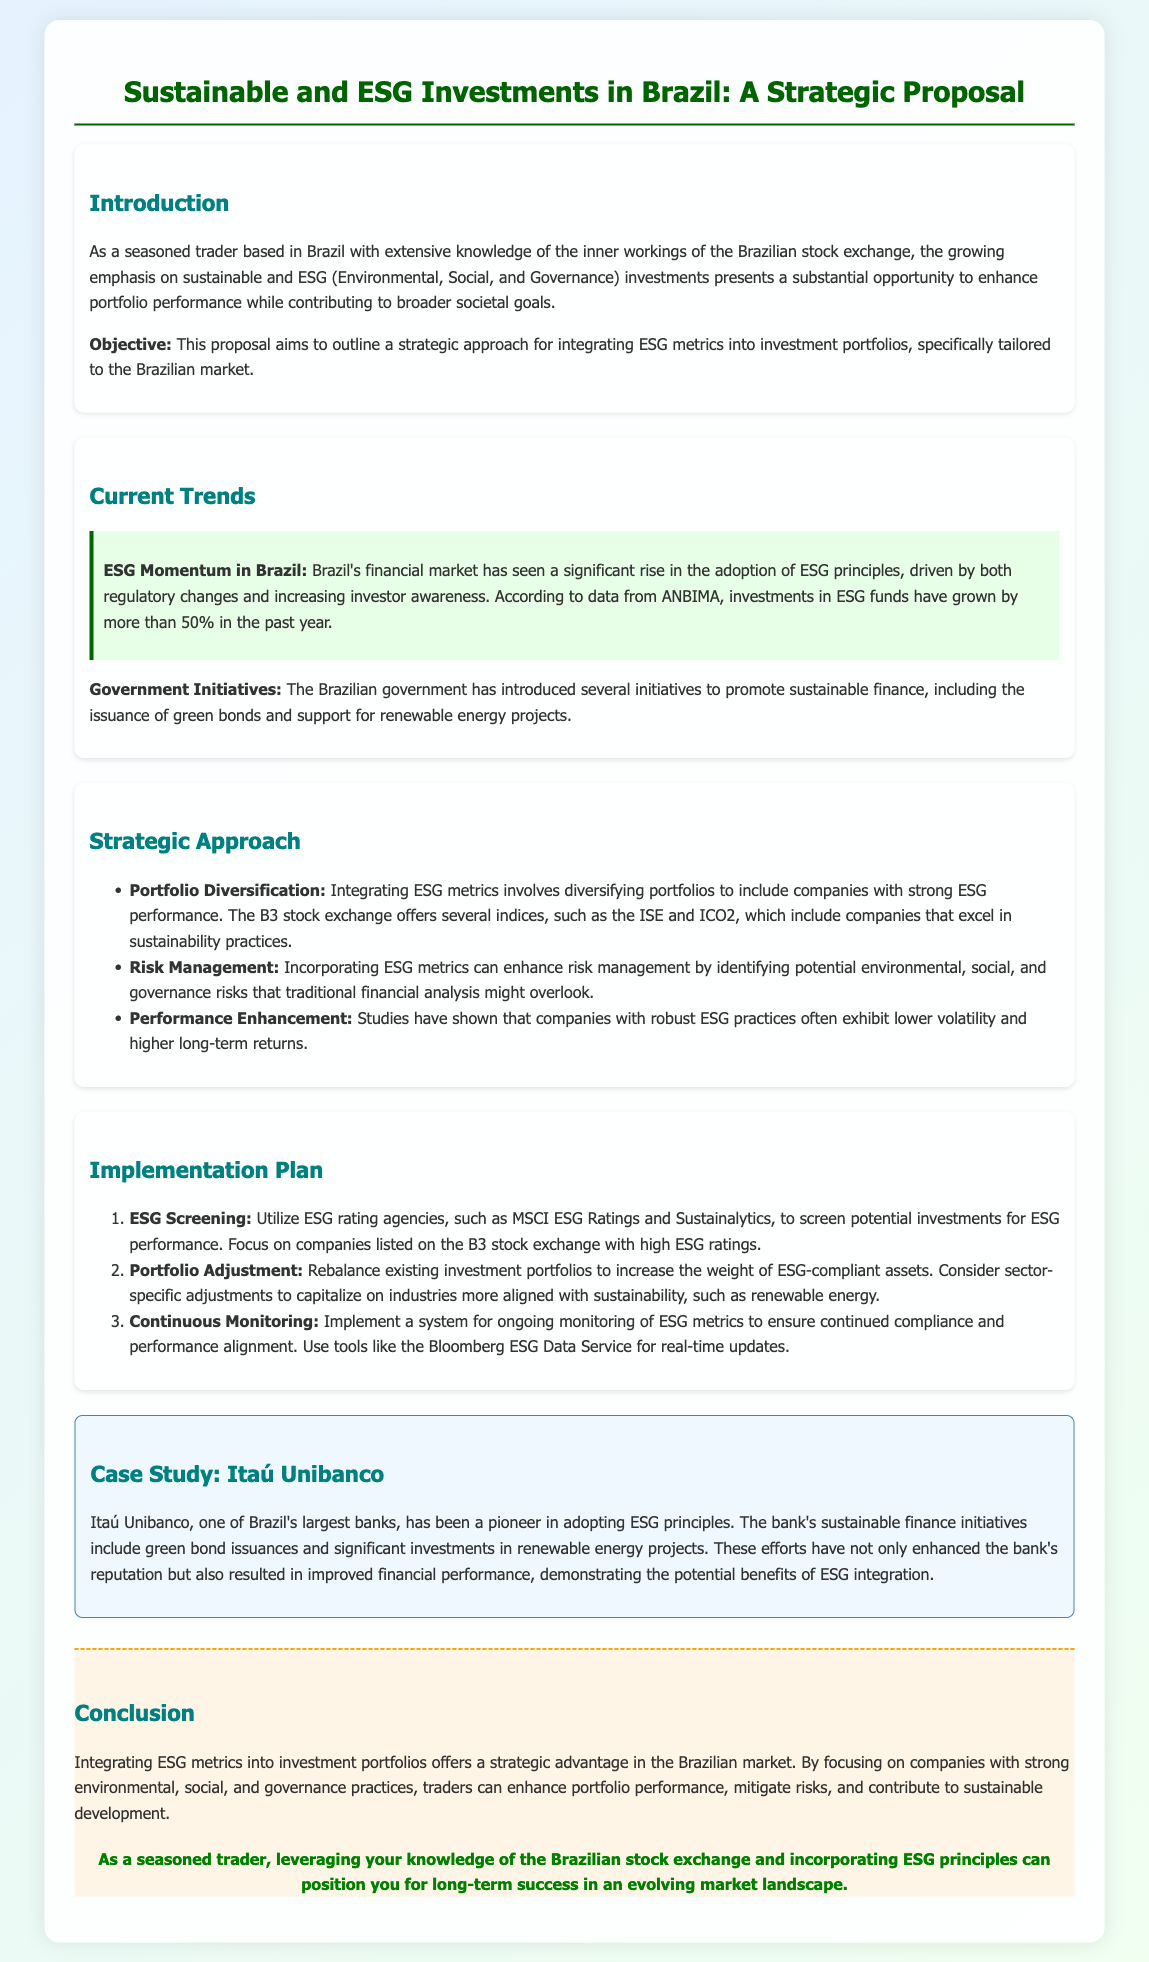what is the main objective of the proposal? The objective is to outline a strategic approach for integrating ESG metrics into investment portfolios, specifically tailored to the Brazilian market.
Answer: strategic approach for integrating ESG metrics what percentage has ESG fund investment grown in the past year? The document states that investments in ESG funds have grown by more than 50% in the past year.
Answer: more than 50% which stock exchange indices are mentioned for companies excelling in sustainability practices? The proposal mentions the ISE and ICO2 indices of the B3 stock exchange that include companies with strong ESG performance.
Answer: ISE and ICO2 what is the first step in the implementation plan? The first step is utilizing ESG rating agencies to screen potential investments for ESG performance.
Answer: ESG Screening which case study is highlighted in the proposal? The case study highlighted is about Itaú Unibanco, a Brazilian bank that has adopted ESG principles.
Answer: Itaú Unibanco how does the proposal suggest monitoring ESG metrics? The proposal suggests implementing a system for ongoing monitoring of ESG metrics using tools like the Bloomberg ESG Data Service.
Answer: Bloomberg ESG Data Service what significant initiative has the Brazilian government introduced? The government has introduced the issuance of green bonds as a significant initiative to promote sustainable finance.
Answer: green bonds which potential benefit of ESG integration is mentioned regarding company performance? Companies with robust ESG practices often exhibit lower volatility and higher long-term returns.
Answer: lower volatility and higher long-term returns 